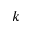<formula> <loc_0><loc_0><loc_500><loc_500>k</formula> 